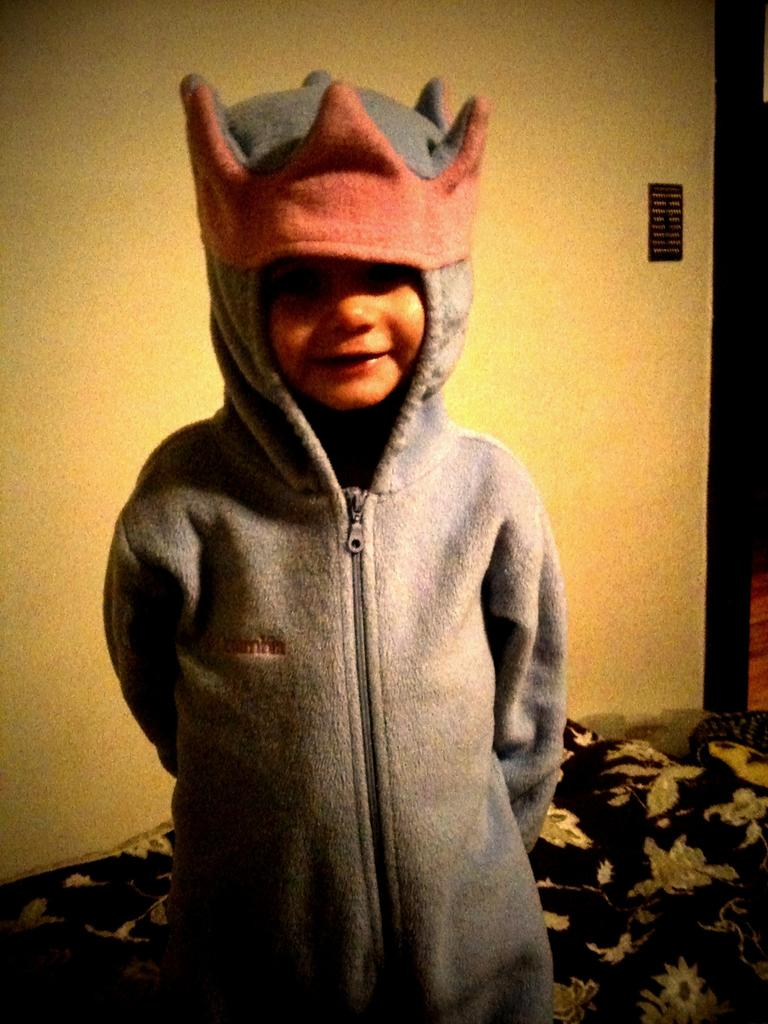What is the main subject of the image? The main subject of the image is a kid standing. What is the kid wearing in the image? The kid is wearing a sweater in the image. What color is the background wall in the image? The background wall is yellow in color. How many crows can be seen sitting on the sweater in the image? There are no crows present in the image, so none can be seen sitting on the sweater. 